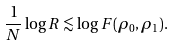<formula> <loc_0><loc_0><loc_500><loc_500>\frac { 1 } { N } \log R \lesssim \log F ( \rho _ { 0 } , \rho _ { 1 } ) .</formula> 